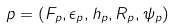<formula> <loc_0><loc_0><loc_500><loc_500>p = ( F _ { p } , \epsilon _ { p } , h _ { p } , R _ { p } , \psi _ { p } )</formula> 